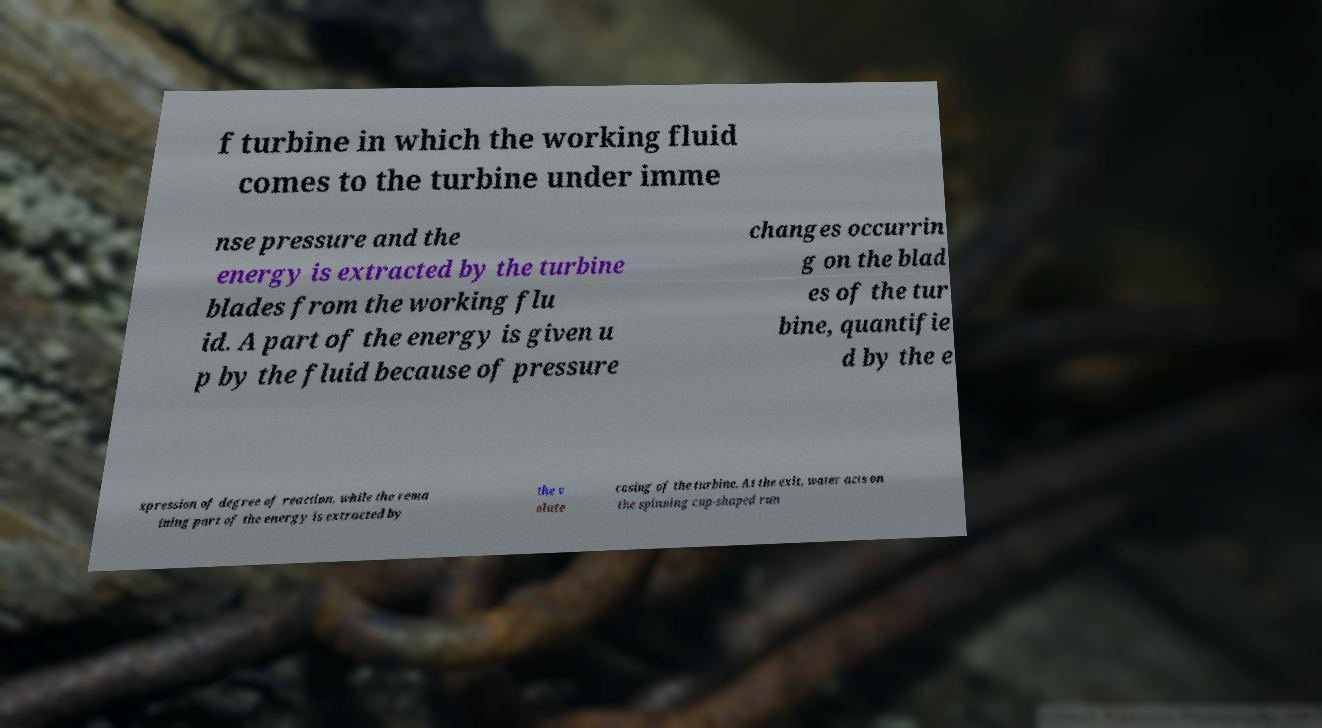Could you extract and type out the text from this image? f turbine in which the working fluid comes to the turbine under imme nse pressure and the energy is extracted by the turbine blades from the working flu id. A part of the energy is given u p by the fluid because of pressure changes occurrin g on the blad es of the tur bine, quantifie d by the e xpression of degree of reaction, while the rema ining part of the energy is extracted by the v olute casing of the turbine. At the exit, water acts on the spinning cup-shaped run 